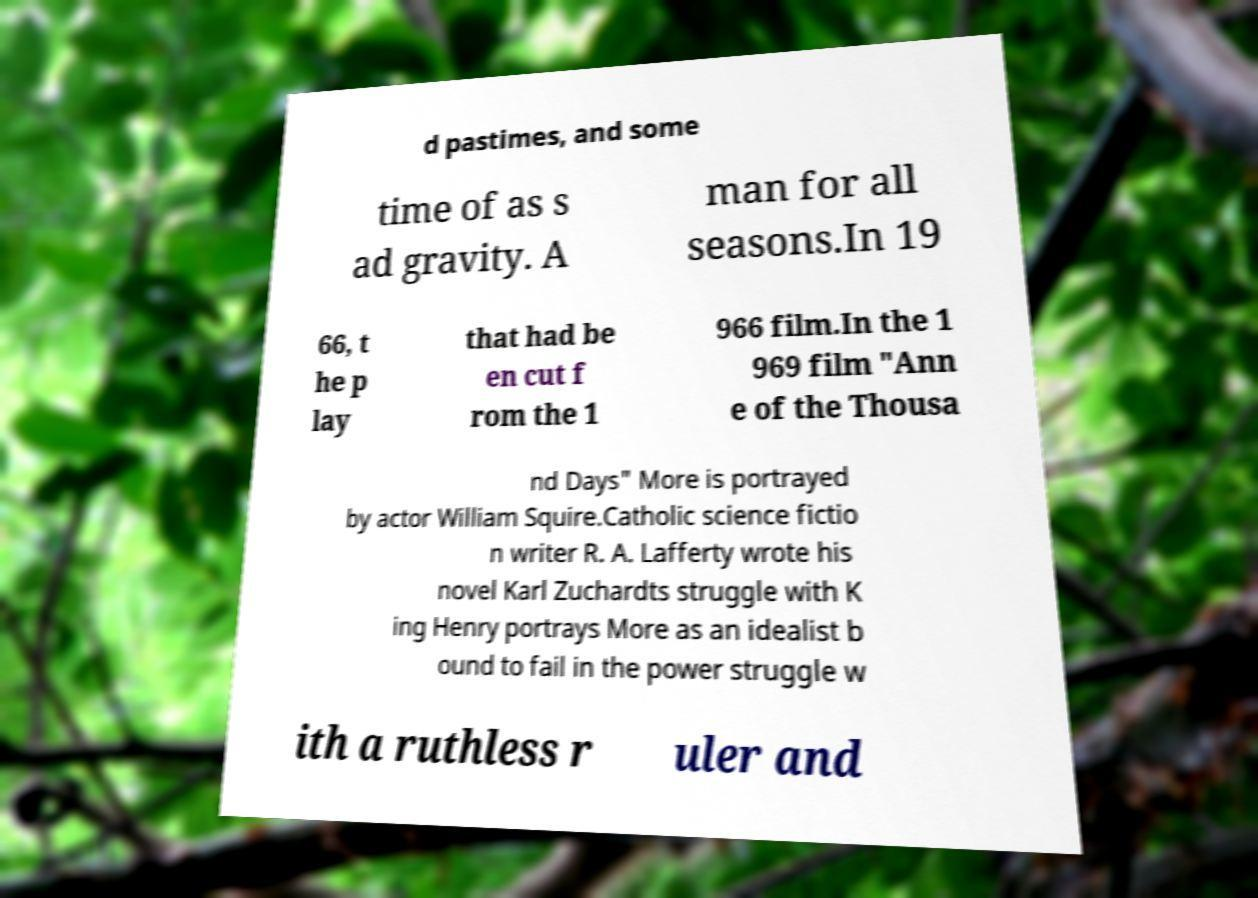For documentation purposes, I need the text within this image transcribed. Could you provide that? d pastimes, and some time of as s ad gravity. A man for all seasons.In 19 66, t he p lay that had be en cut f rom the 1 966 film.In the 1 969 film "Ann e of the Thousa nd Days" More is portrayed by actor William Squire.Catholic science fictio n writer R. A. Lafferty wrote his novel Karl Zuchardts struggle with K ing Henry portrays More as an idealist b ound to fail in the power struggle w ith a ruthless r uler and 